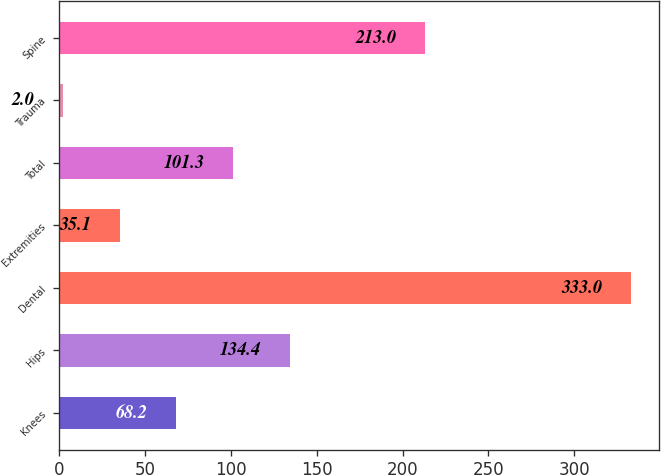Convert chart. <chart><loc_0><loc_0><loc_500><loc_500><bar_chart><fcel>Knees<fcel>Hips<fcel>Dental<fcel>Extremities<fcel>Total<fcel>Trauma<fcel>Spine<nl><fcel>68.2<fcel>134.4<fcel>333<fcel>35.1<fcel>101.3<fcel>2<fcel>213<nl></chart> 